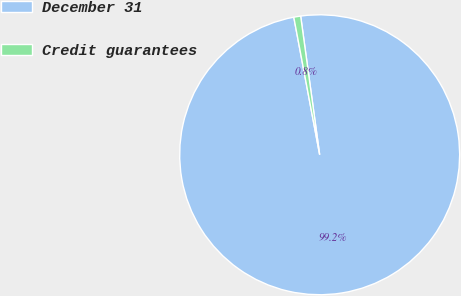Convert chart to OTSL. <chart><loc_0><loc_0><loc_500><loc_500><pie_chart><fcel>December 31<fcel>Credit guarantees<nl><fcel>99.21%<fcel>0.79%<nl></chart> 